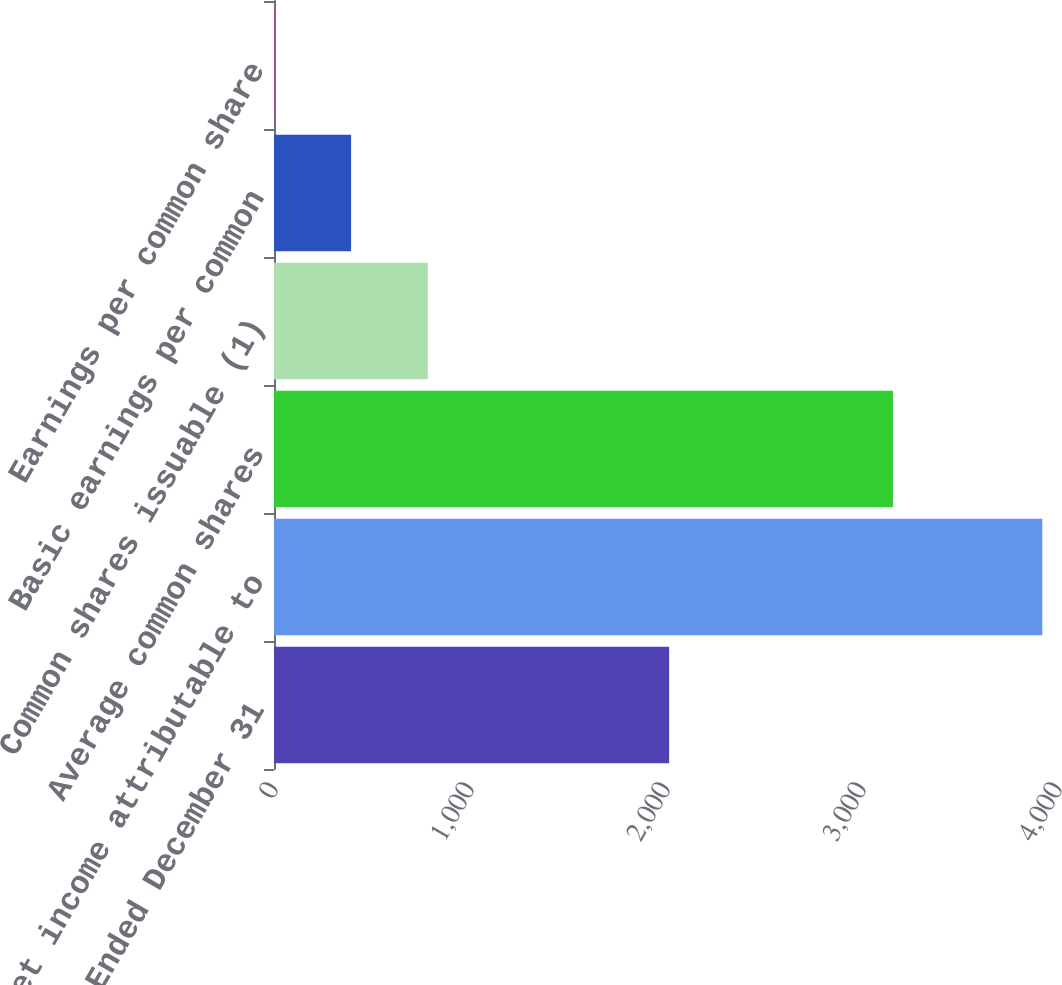Convert chart to OTSL. <chart><loc_0><loc_0><loc_500><loc_500><bar_chart><fcel>Years Ended December 31<fcel>Net income attributable to<fcel>Average common shares<fcel>Common shares issuable (1)<fcel>Basic earnings per common<fcel>Earnings per common share<nl><fcel>2016<fcel>3920<fcel>3157.86<fcel>785.13<fcel>393.27<fcel>1.41<nl></chart> 